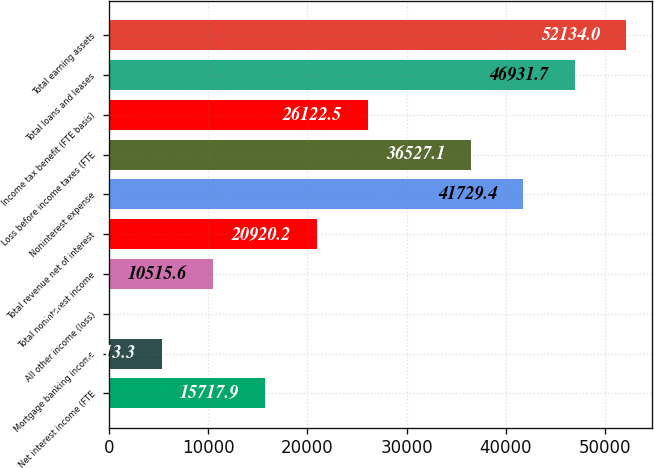Convert chart. <chart><loc_0><loc_0><loc_500><loc_500><bar_chart><fcel>Net interest income (FTE<fcel>Mortgage banking income<fcel>All other income (loss)<fcel>Total noninterest income<fcel>Total revenue net of interest<fcel>Noninterest expense<fcel>Loss before income taxes (FTE<fcel>Income tax benefit (FTE basis)<fcel>Total loans and leases<fcel>Total earning assets<nl><fcel>15717.9<fcel>5313.3<fcel>111<fcel>10515.6<fcel>20920.2<fcel>41729.4<fcel>36527.1<fcel>26122.5<fcel>46931.7<fcel>52134<nl></chart> 